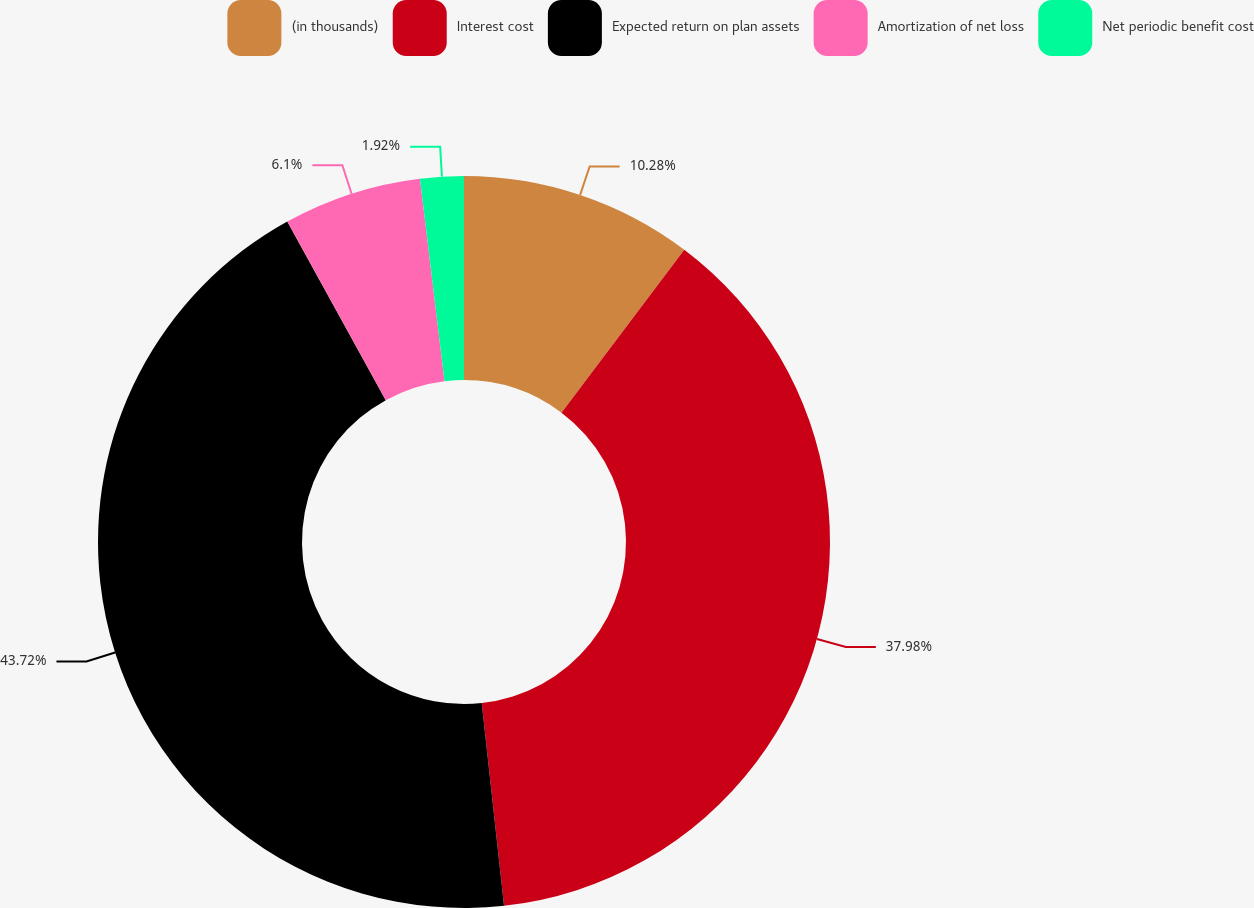Convert chart. <chart><loc_0><loc_0><loc_500><loc_500><pie_chart><fcel>(in thousands)<fcel>Interest cost<fcel>Expected return on plan assets<fcel>Amortization of net loss<fcel>Net periodic benefit cost<nl><fcel>10.28%<fcel>37.98%<fcel>43.73%<fcel>6.1%<fcel>1.92%<nl></chart> 